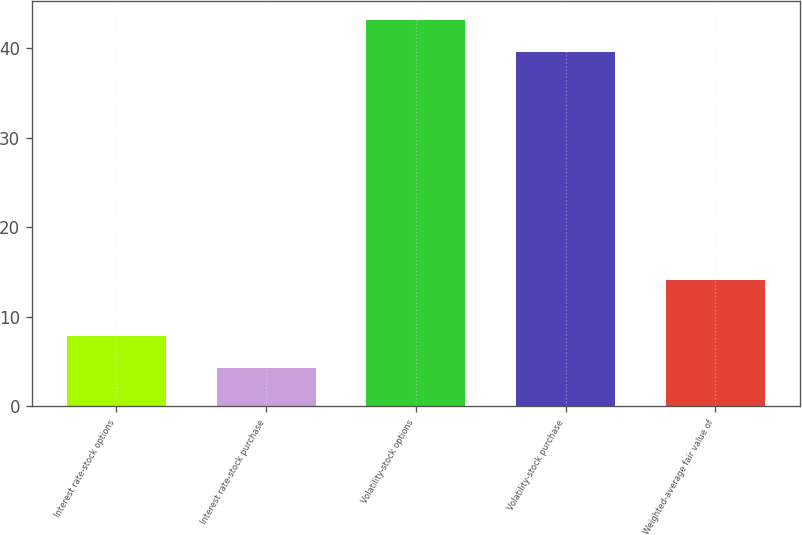Convert chart. <chart><loc_0><loc_0><loc_500><loc_500><bar_chart><fcel>Interest rate-stock options<fcel>Interest rate-stock purchase<fcel>Volatility-stock options<fcel>Volatility-stock purchase<fcel>Weighted-average fair value of<nl><fcel>7.9<fcel>4.29<fcel>43.17<fcel>39.56<fcel>14.06<nl></chart> 